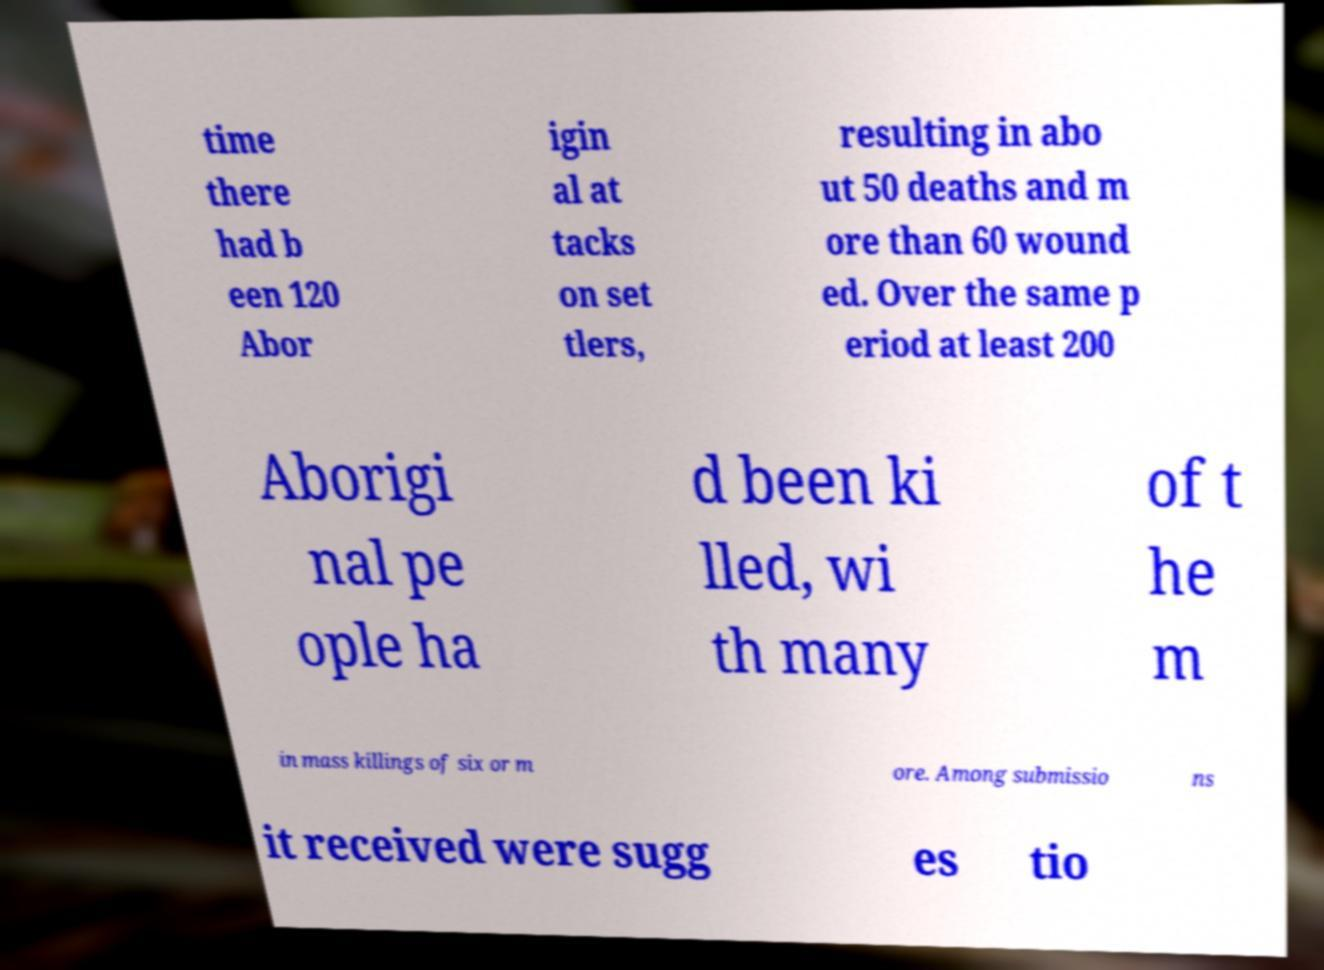Could you assist in decoding the text presented in this image and type it out clearly? time there had b een 120 Abor igin al at tacks on set tlers, resulting in abo ut 50 deaths and m ore than 60 wound ed. Over the same p eriod at least 200 Aborigi nal pe ople ha d been ki lled, wi th many of t he m in mass killings of six or m ore. Among submissio ns it received were sugg es tio 